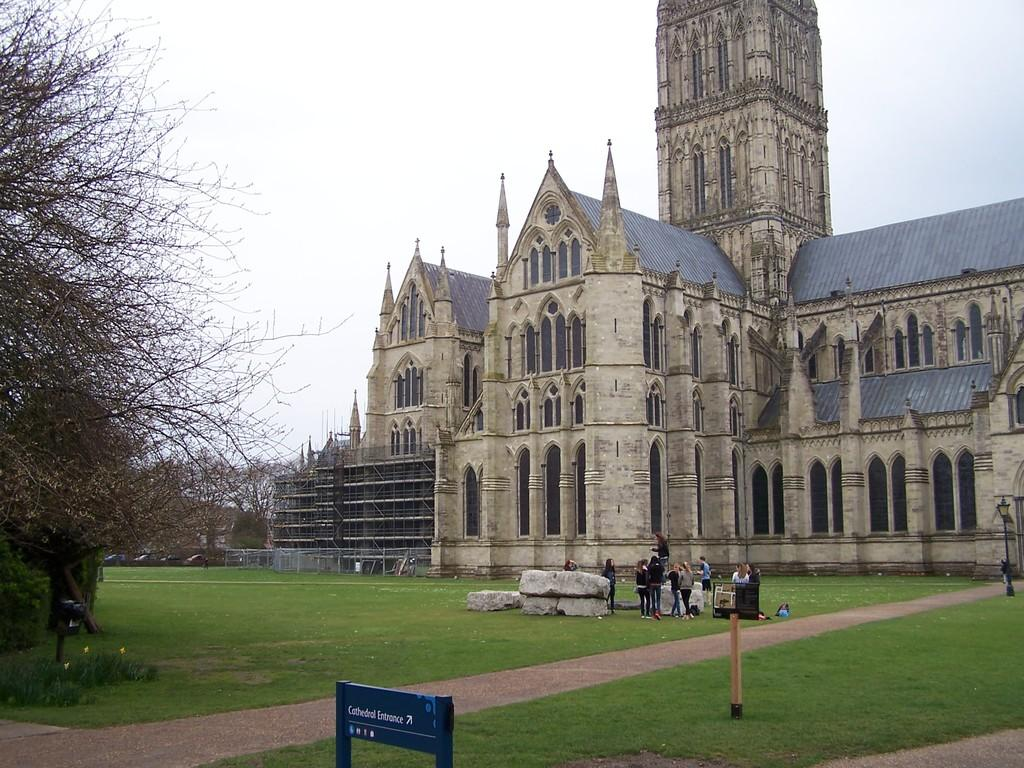What is happening on the ground in the image? There are people on the ground in the image. What can be seen in the background of the image? There is a building and trees in the background of the image. What is visible in the sky in the image? The sky is visible in the background of the image. What type of experience does the grandfather have with the men in the image? There is no mention of a grandfather or men in the image, so it is not possible to answer this question. 